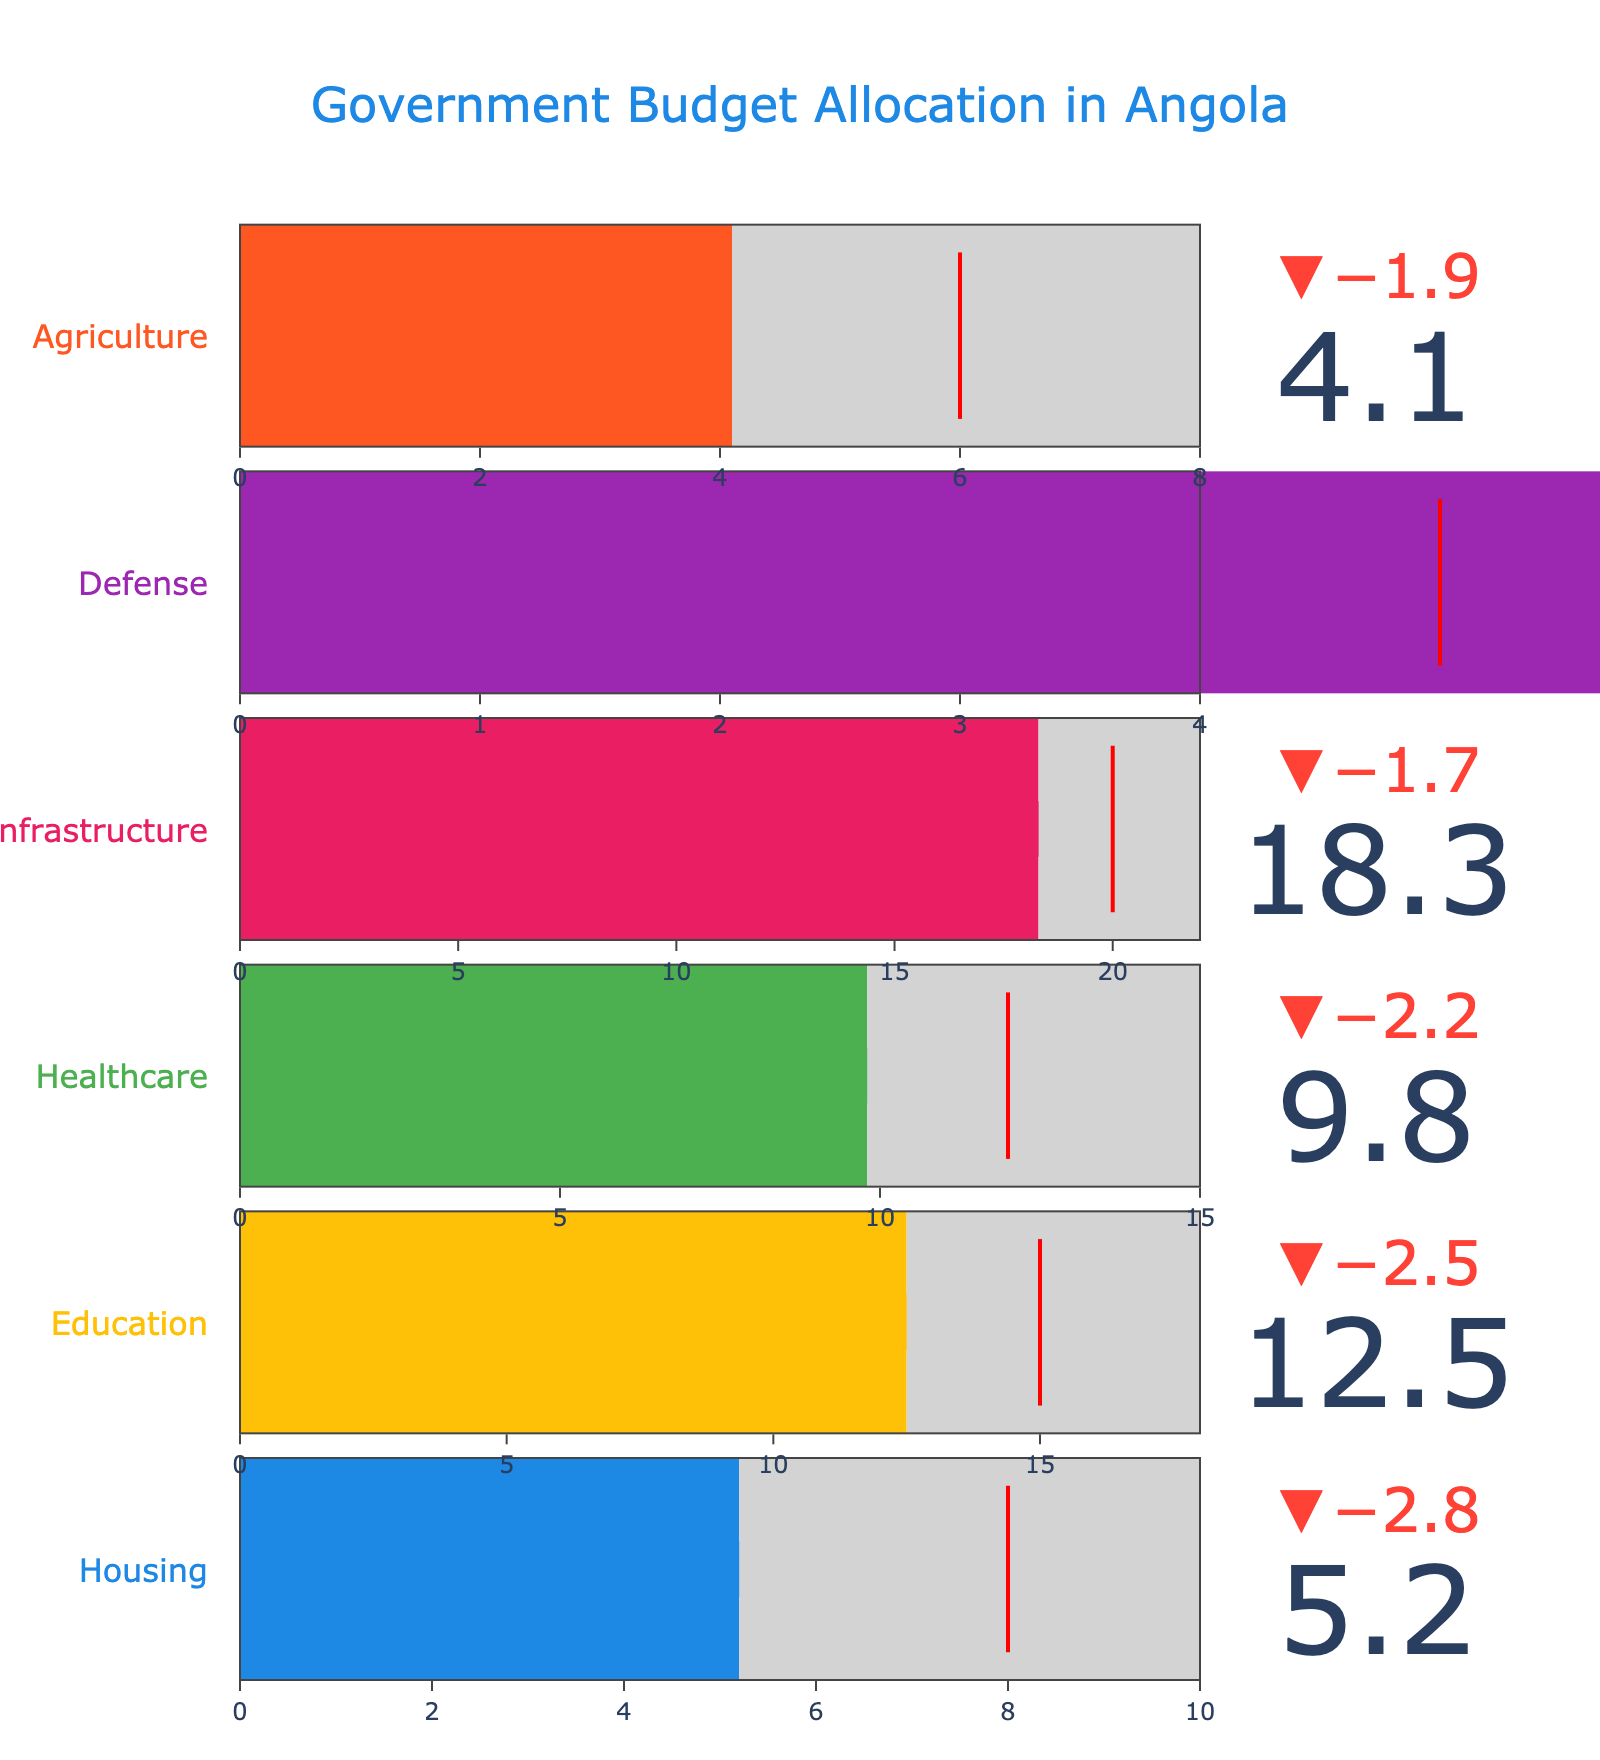What is the title of the figure? The title is located at the top of the figure, using a large font size and blue color. It reads "Government Budget Allocation in Angola".
Answer: Government Budget Allocation in Angola How many sectors are presented in the figure? By observing the figure, there are six different sectors listed, each represented with its own bullet chart.
Answer: Six Which sector came closest to its target? Looking at the delta indicators for each sector, Defense has an actual value (6.7) close to its target (5) compared to the other sectors.
Answer: Defense What is the benchmark value for the Healthcare sector? The benchmark value for each sector is indicated by the upper limit of the bullet gauge. For Healthcare, the upper limit is 15.
Answer: 15 By how much did the actual value for Housing fall short of the target? The actual value for Housing is 5.2, and the target is 8. Thus, the shortfall is 8 - 5.2 = 2.8.
Answer: 2.8 Which sector has the highest actual budget allocation? Comparing the 'Actual' values for all sectors, Infrastructure has the highest actual budget allocation of 18.3.
Answer: Infrastructure How much higher is the benchmark for Education compared to Agriculture? The benchmark value for Education is 18, and for Agriculture, it is 8. The difference is 18 - 8 = 10.
Answer: 10 Compare the actual budget allocation for Housing and Agriculture. Which one is higher? By comparing the actual values, Housing has an actual value of 5.2, and Agriculture has 4.1. Thus, Housing is higher.
Answer: Housing What percentage of Infrastructure’s target is its actual value? Infrastructure’s actual value is 18.3, and its target is 20. The percentage is (18.3 / 20) * 100 = 91.5%.
Answer: 91.5% If you sum the target values for Healthcare and Education, what is the total? The target values are 12 for Healthcare and 15 for Education. The total is 12 + 15 = 27.
Answer: 27 